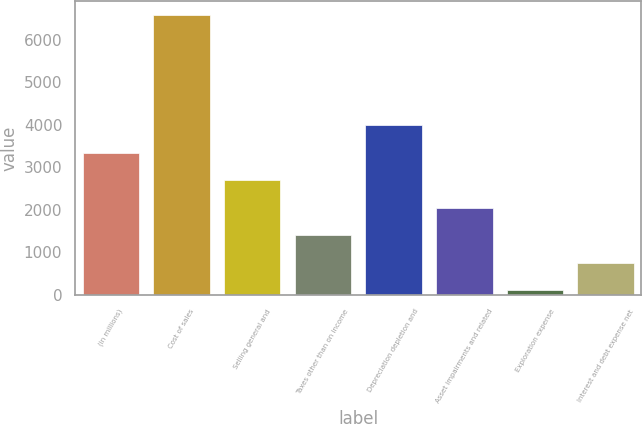Convert chart to OTSL. <chart><loc_0><loc_0><loc_500><loc_500><bar_chart><fcel>(in millions)<fcel>Cost of sales<fcel>Selling general and<fcel>Taxes other than on income<fcel>Depreciation depletion and<fcel>Asset impairments and related<fcel>Exploration expense<fcel>Interest and debt expense net<nl><fcel>3339<fcel>6568<fcel>2693.2<fcel>1401.6<fcel>3984.8<fcel>2047.4<fcel>110<fcel>755.8<nl></chart> 